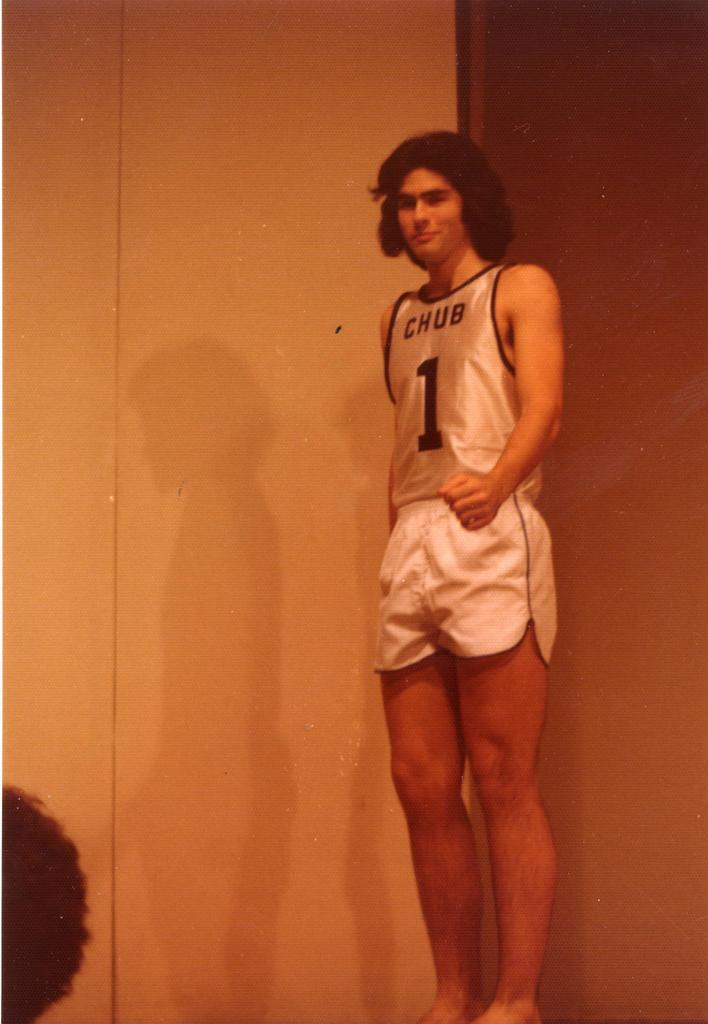<image>
Render a clear and concise summary of the photo. A man in a number 1 Chub jersey. 